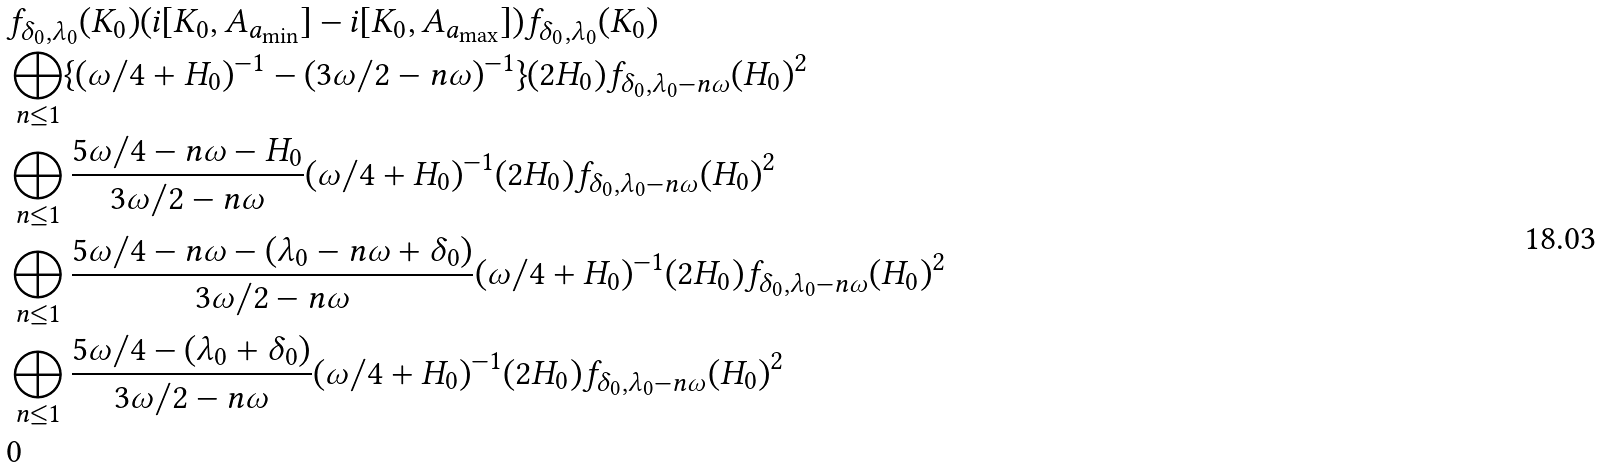Convert formula to latex. <formula><loc_0><loc_0><loc_500><loc_500>& f _ { \delta _ { 0 } , \lambda _ { 0 } } ( K _ { 0 } ) ( i [ K _ { 0 } , A _ { a _ { \min } } ] - i [ K _ { 0 } , A _ { a _ { \max } } ] ) f _ { \delta _ { 0 } , \lambda _ { 0 } } ( K _ { 0 } ) \\ & \bigoplus _ { n \leq 1 } \{ ( \omega / 4 + H _ { 0 } ) ^ { - 1 } - ( 3 \omega / 2 - n \omega ) ^ { - 1 } \} ( 2 H _ { 0 } ) f _ { \delta _ { 0 } , \lambda _ { 0 } - n \omega } ( H _ { 0 } ) ^ { 2 } \\ & \bigoplus _ { n \leq 1 } \frac { 5 \omega / 4 - n \omega - H _ { 0 } } { 3 \omega / 2 - n \omega } ( \omega / 4 + H _ { 0 } ) ^ { - 1 } ( 2 H _ { 0 } ) f _ { \delta _ { 0 } , \lambda _ { 0 } - n \omega } ( H _ { 0 } ) ^ { 2 } \\ & \bigoplus _ { n \leq 1 } \frac { 5 \omega / 4 - n \omega - ( \lambda _ { 0 } - n \omega + \delta _ { 0 } ) } { 3 \omega / 2 - n \omega } ( \omega / 4 + H _ { 0 } ) ^ { - 1 } ( 2 H _ { 0 } ) f _ { \delta _ { 0 } , \lambda _ { 0 } - n \omega } ( H _ { 0 } ) ^ { 2 } \\ & \bigoplus _ { n \leq 1 } \frac { 5 \omega / 4 - ( \lambda _ { 0 } + \delta _ { 0 } ) } { 3 \omega / 2 - n \omega } ( \omega / 4 + H _ { 0 } ) ^ { - 1 } ( 2 H _ { 0 } ) f _ { \delta _ { 0 } , \lambda _ { 0 } - n \omega } ( H _ { 0 } ) ^ { 2 } \\ & 0</formula> 